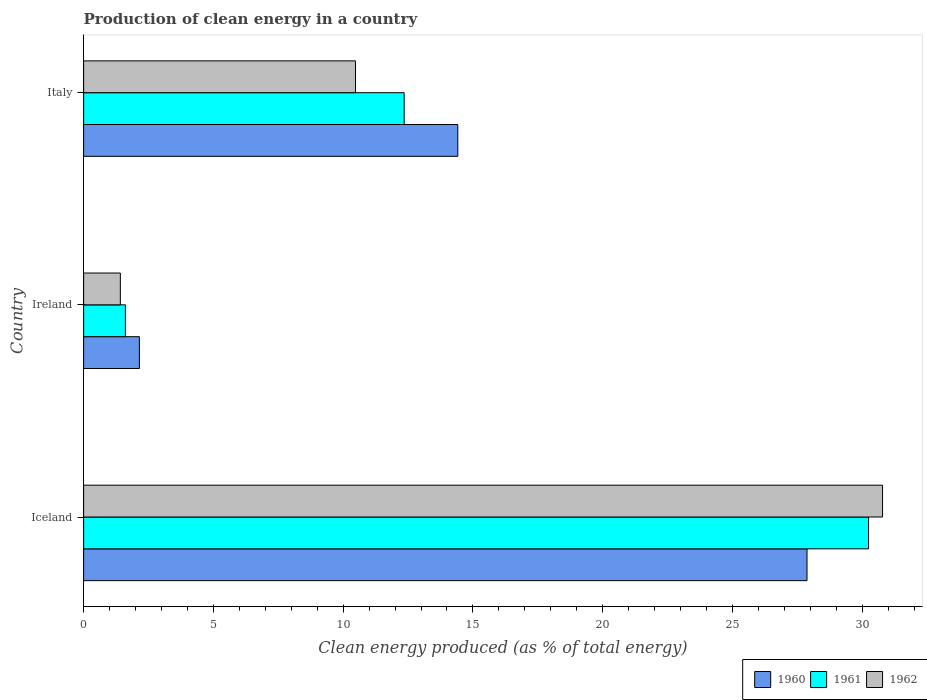How many groups of bars are there?
Ensure brevity in your answer.  3. Are the number of bars per tick equal to the number of legend labels?
Offer a very short reply. Yes. Are the number of bars on each tick of the Y-axis equal?
Provide a succinct answer. Yes. How many bars are there on the 2nd tick from the top?
Your answer should be very brief. 3. How many bars are there on the 2nd tick from the bottom?
Provide a short and direct response. 3. What is the label of the 2nd group of bars from the top?
Provide a short and direct response. Ireland. What is the percentage of clean energy produced in 1961 in Italy?
Your answer should be compact. 12.35. Across all countries, what is the maximum percentage of clean energy produced in 1961?
Offer a very short reply. 30.24. Across all countries, what is the minimum percentage of clean energy produced in 1961?
Keep it short and to the point. 1.61. In which country was the percentage of clean energy produced in 1961 minimum?
Offer a terse response. Ireland. What is the total percentage of clean energy produced in 1961 in the graph?
Offer a terse response. 44.2. What is the difference between the percentage of clean energy produced in 1961 in Ireland and that in Italy?
Make the answer very short. -10.74. What is the difference between the percentage of clean energy produced in 1960 in Italy and the percentage of clean energy produced in 1962 in Iceland?
Provide a succinct answer. -16.37. What is the average percentage of clean energy produced in 1961 per country?
Offer a very short reply. 14.73. What is the difference between the percentage of clean energy produced in 1961 and percentage of clean energy produced in 1960 in Iceland?
Offer a very short reply. 2.37. What is the ratio of the percentage of clean energy produced in 1962 in Iceland to that in Ireland?
Provide a succinct answer. 21.76. What is the difference between the highest and the second highest percentage of clean energy produced in 1960?
Offer a very short reply. 13.46. What is the difference between the highest and the lowest percentage of clean energy produced in 1960?
Give a very brief answer. 25.72. In how many countries, is the percentage of clean energy produced in 1960 greater than the average percentage of clean energy produced in 1960 taken over all countries?
Offer a very short reply. 1. Is the sum of the percentage of clean energy produced in 1960 in Iceland and Ireland greater than the maximum percentage of clean energy produced in 1961 across all countries?
Keep it short and to the point. No. What does the 3rd bar from the top in Ireland represents?
Keep it short and to the point. 1960. Does the graph contain any zero values?
Offer a very short reply. No. Where does the legend appear in the graph?
Your answer should be very brief. Bottom right. How many legend labels are there?
Make the answer very short. 3. How are the legend labels stacked?
Your answer should be compact. Horizontal. What is the title of the graph?
Offer a terse response. Production of clean energy in a country. Does "1981" appear as one of the legend labels in the graph?
Make the answer very short. No. What is the label or title of the X-axis?
Ensure brevity in your answer.  Clean energy produced (as % of total energy). What is the label or title of the Y-axis?
Make the answer very short. Country. What is the Clean energy produced (as % of total energy) of 1960 in Iceland?
Make the answer very short. 27.87. What is the Clean energy produced (as % of total energy) of 1961 in Iceland?
Give a very brief answer. 30.24. What is the Clean energy produced (as % of total energy) of 1962 in Iceland?
Keep it short and to the point. 30.78. What is the Clean energy produced (as % of total energy) of 1960 in Ireland?
Your answer should be compact. 2.15. What is the Clean energy produced (as % of total energy) in 1961 in Ireland?
Offer a terse response. 1.61. What is the Clean energy produced (as % of total energy) in 1962 in Ireland?
Give a very brief answer. 1.41. What is the Clean energy produced (as % of total energy) in 1960 in Italy?
Your response must be concise. 14.42. What is the Clean energy produced (as % of total energy) in 1961 in Italy?
Offer a very short reply. 12.35. What is the Clean energy produced (as % of total energy) of 1962 in Italy?
Offer a very short reply. 10.48. Across all countries, what is the maximum Clean energy produced (as % of total energy) of 1960?
Provide a succinct answer. 27.87. Across all countries, what is the maximum Clean energy produced (as % of total energy) of 1961?
Your answer should be compact. 30.24. Across all countries, what is the maximum Clean energy produced (as % of total energy) in 1962?
Offer a very short reply. 30.78. Across all countries, what is the minimum Clean energy produced (as % of total energy) of 1960?
Provide a succinct answer. 2.15. Across all countries, what is the minimum Clean energy produced (as % of total energy) in 1961?
Offer a very short reply. 1.61. Across all countries, what is the minimum Clean energy produced (as % of total energy) of 1962?
Provide a short and direct response. 1.41. What is the total Clean energy produced (as % of total energy) of 1960 in the graph?
Offer a terse response. 44.44. What is the total Clean energy produced (as % of total energy) of 1961 in the graph?
Give a very brief answer. 44.2. What is the total Clean energy produced (as % of total energy) in 1962 in the graph?
Your answer should be very brief. 42.67. What is the difference between the Clean energy produced (as % of total energy) in 1960 in Iceland and that in Ireland?
Offer a very short reply. 25.72. What is the difference between the Clean energy produced (as % of total energy) in 1961 in Iceland and that in Ireland?
Make the answer very short. 28.63. What is the difference between the Clean energy produced (as % of total energy) in 1962 in Iceland and that in Ireland?
Offer a very short reply. 29.37. What is the difference between the Clean energy produced (as % of total energy) in 1960 in Iceland and that in Italy?
Provide a succinct answer. 13.46. What is the difference between the Clean energy produced (as % of total energy) of 1961 in Iceland and that in Italy?
Your answer should be compact. 17.89. What is the difference between the Clean energy produced (as % of total energy) of 1962 in Iceland and that in Italy?
Offer a very short reply. 20.31. What is the difference between the Clean energy produced (as % of total energy) in 1960 in Ireland and that in Italy?
Keep it short and to the point. -12.27. What is the difference between the Clean energy produced (as % of total energy) of 1961 in Ireland and that in Italy?
Offer a very short reply. -10.74. What is the difference between the Clean energy produced (as % of total energy) in 1962 in Ireland and that in Italy?
Ensure brevity in your answer.  -9.06. What is the difference between the Clean energy produced (as % of total energy) of 1960 in Iceland and the Clean energy produced (as % of total energy) of 1961 in Ireland?
Your answer should be compact. 26.26. What is the difference between the Clean energy produced (as % of total energy) in 1960 in Iceland and the Clean energy produced (as % of total energy) in 1962 in Ireland?
Make the answer very short. 26.46. What is the difference between the Clean energy produced (as % of total energy) in 1961 in Iceland and the Clean energy produced (as % of total energy) in 1962 in Ireland?
Your response must be concise. 28.83. What is the difference between the Clean energy produced (as % of total energy) of 1960 in Iceland and the Clean energy produced (as % of total energy) of 1961 in Italy?
Your answer should be compact. 15.52. What is the difference between the Clean energy produced (as % of total energy) in 1960 in Iceland and the Clean energy produced (as % of total energy) in 1962 in Italy?
Provide a short and direct response. 17.4. What is the difference between the Clean energy produced (as % of total energy) of 1961 in Iceland and the Clean energy produced (as % of total energy) of 1962 in Italy?
Keep it short and to the point. 19.77. What is the difference between the Clean energy produced (as % of total energy) of 1960 in Ireland and the Clean energy produced (as % of total energy) of 1961 in Italy?
Give a very brief answer. -10.2. What is the difference between the Clean energy produced (as % of total energy) of 1960 in Ireland and the Clean energy produced (as % of total energy) of 1962 in Italy?
Offer a terse response. -8.33. What is the difference between the Clean energy produced (as % of total energy) in 1961 in Ireland and the Clean energy produced (as % of total energy) in 1962 in Italy?
Ensure brevity in your answer.  -8.87. What is the average Clean energy produced (as % of total energy) of 1960 per country?
Ensure brevity in your answer.  14.81. What is the average Clean energy produced (as % of total energy) of 1961 per country?
Offer a very short reply. 14.73. What is the average Clean energy produced (as % of total energy) of 1962 per country?
Make the answer very short. 14.22. What is the difference between the Clean energy produced (as % of total energy) of 1960 and Clean energy produced (as % of total energy) of 1961 in Iceland?
Offer a very short reply. -2.37. What is the difference between the Clean energy produced (as % of total energy) of 1960 and Clean energy produced (as % of total energy) of 1962 in Iceland?
Give a very brief answer. -2.91. What is the difference between the Clean energy produced (as % of total energy) of 1961 and Clean energy produced (as % of total energy) of 1962 in Iceland?
Keep it short and to the point. -0.54. What is the difference between the Clean energy produced (as % of total energy) of 1960 and Clean energy produced (as % of total energy) of 1961 in Ireland?
Your answer should be compact. 0.54. What is the difference between the Clean energy produced (as % of total energy) in 1960 and Clean energy produced (as % of total energy) in 1962 in Ireland?
Provide a succinct answer. 0.73. What is the difference between the Clean energy produced (as % of total energy) of 1961 and Clean energy produced (as % of total energy) of 1962 in Ireland?
Keep it short and to the point. 0.19. What is the difference between the Clean energy produced (as % of total energy) of 1960 and Clean energy produced (as % of total energy) of 1961 in Italy?
Offer a very short reply. 2.07. What is the difference between the Clean energy produced (as % of total energy) of 1960 and Clean energy produced (as % of total energy) of 1962 in Italy?
Make the answer very short. 3.94. What is the difference between the Clean energy produced (as % of total energy) in 1961 and Clean energy produced (as % of total energy) in 1962 in Italy?
Your answer should be compact. 1.87. What is the ratio of the Clean energy produced (as % of total energy) in 1960 in Iceland to that in Ireland?
Make the answer very short. 12.97. What is the ratio of the Clean energy produced (as % of total energy) of 1961 in Iceland to that in Ireland?
Ensure brevity in your answer.  18.79. What is the ratio of the Clean energy produced (as % of total energy) of 1962 in Iceland to that in Ireland?
Offer a very short reply. 21.76. What is the ratio of the Clean energy produced (as % of total energy) in 1960 in Iceland to that in Italy?
Provide a short and direct response. 1.93. What is the ratio of the Clean energy produced (as % of total energy) of 1961 in Iceland to that in Italy?
Give a very brief answer. 2.45. What is the ratio of the Clean energy produced (as % of total energy) of 1962 in Iceland to that in Italy?
Keep it short and to the point. 2.94. What is the ratio of the Clean energy produced (as % of total energy) of 1960 in Ireland to that in Italy?
Provide a short and direct response. 0.15. What is the ratio of the Clean energy produced (as % of total energy) of 1961 in Ireland to that in Italy?
Your answer should be compact. 0.13. What is the ratio of the Clean energy produced (as % of total energy) in 1962 in Ireland to that in Italy?
Keep it short and to the point. 0.14. What is the difference between the highest and the second highest Clean energy produced (as % of total energy) of 1960?
Give a very brief answer. 13.46. What is the difference between the highest and the second highest Clean energy produced (as % of total energy) of 1961?
Your answer should be compact. 17.89. What is the difference between the highest and the second highest Clean energy produced (as % of total energy) in 1962?
Your answer should be compact. 20.31. What is the difference between the highest and the lowest Clean energy produced (as % of total energy) in 1960?
Offer a very short reply. 25.72. What is the difference between the highest and the lowest Clean energy produced (as % of total energy) in 1961?
Your answer should be very brief. 28.63. What is the difference between the highest and the lowest Clean energy produced (as % of total energy) in 1962?
Give a very brief answer. 29.37. 